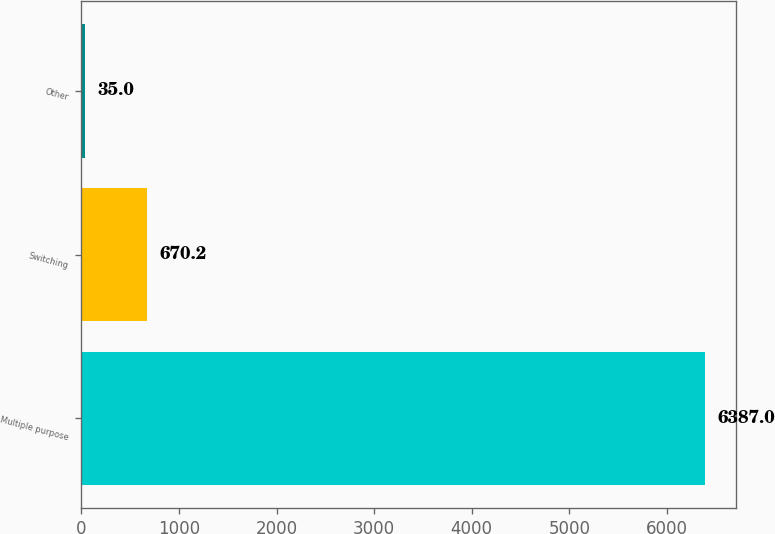Convert chart to OTSL. <chart><loc_0><loc_0><loc_500><loc_500><bar_chart><fcel>Multiple purpose<fcel>Switching<fcel>Other<nl><fcel>6387<fcel>670.2<fcel>35<nl></chart> 